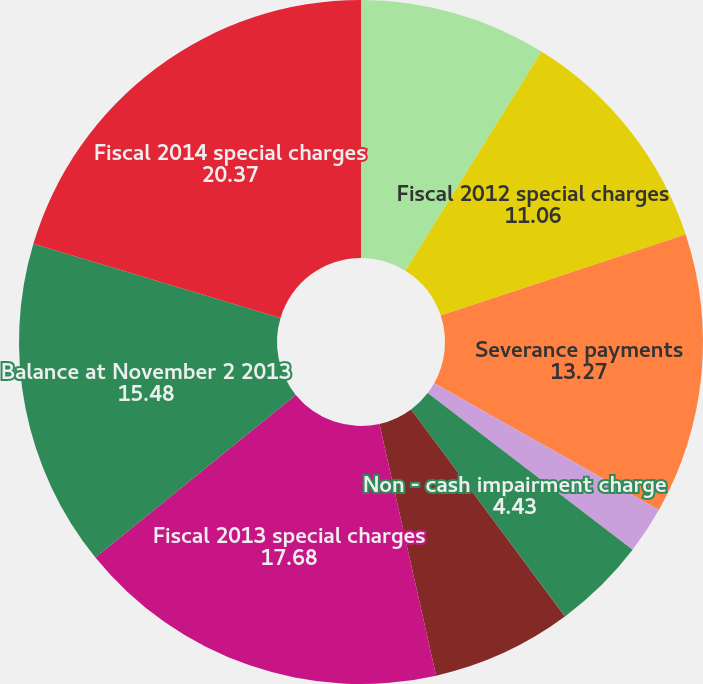Convert chart. <chart><loc_0><loc_0><loc_500><loc_500><pie_chart><fcel>Balance at October 29 2011<fcel>Fiscal 2012 special charges<fcel>Severance payments<fcel>Facility closure costs<fcel>Non - cash impairment charge<fcel>Effect of foreign currency on<fcel>Balance at November 3 2012<fcel>Fiscal 2013 special charges<fcel>Balance at November 2 2013<fcel>Fiscal 2014 special charges<nl><fcel>8.85%<fcel>11.06%<fcel>13.27%<fcel>2.22%<fcel>4.43%<fcel>0.01%<fcel>6.64%<fcel>17.68%<fcel>15.48%<fcel>20.37%<nl></chart> 